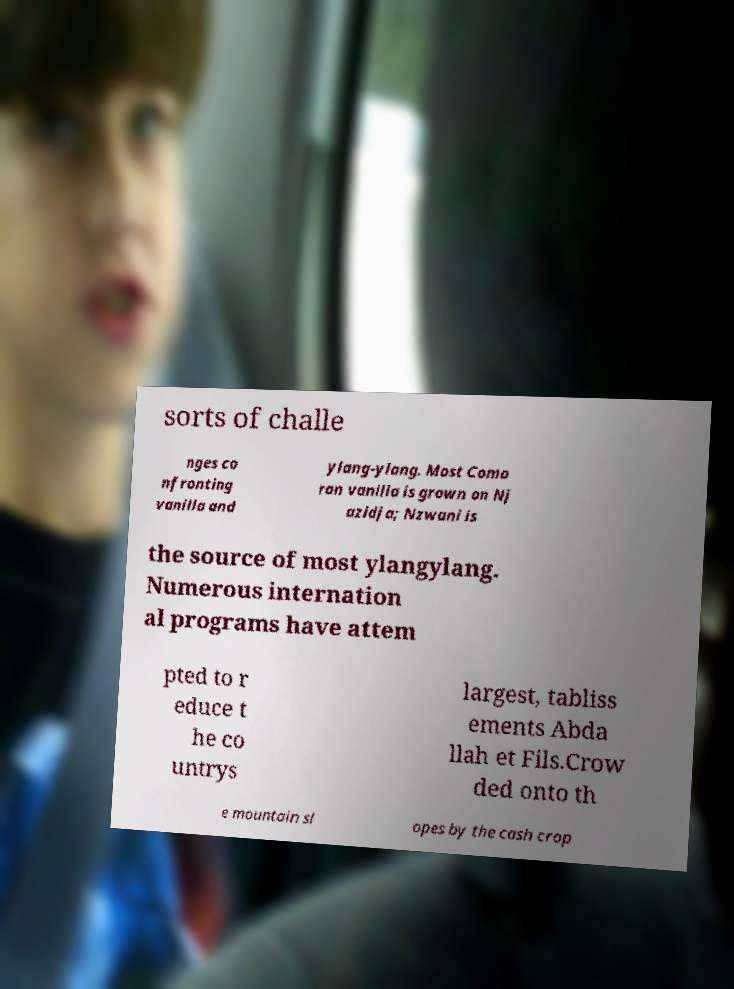Can you read and provide the text displayed in the image?This photo seems to have some interesting text. Can you extract and type it out for me? sorts of challe nges co nfronting vanilla and ylang-ylang. Most Como ran vanilla is grown on Nj azidja; Nzwani is the source of most ylangylang. Numerous internation al programs have attem pted to r educe t he co untrys largest, tabliss ements Abda llah et Fils.Crow ded onto th e mountain sl opes by the cash crop 